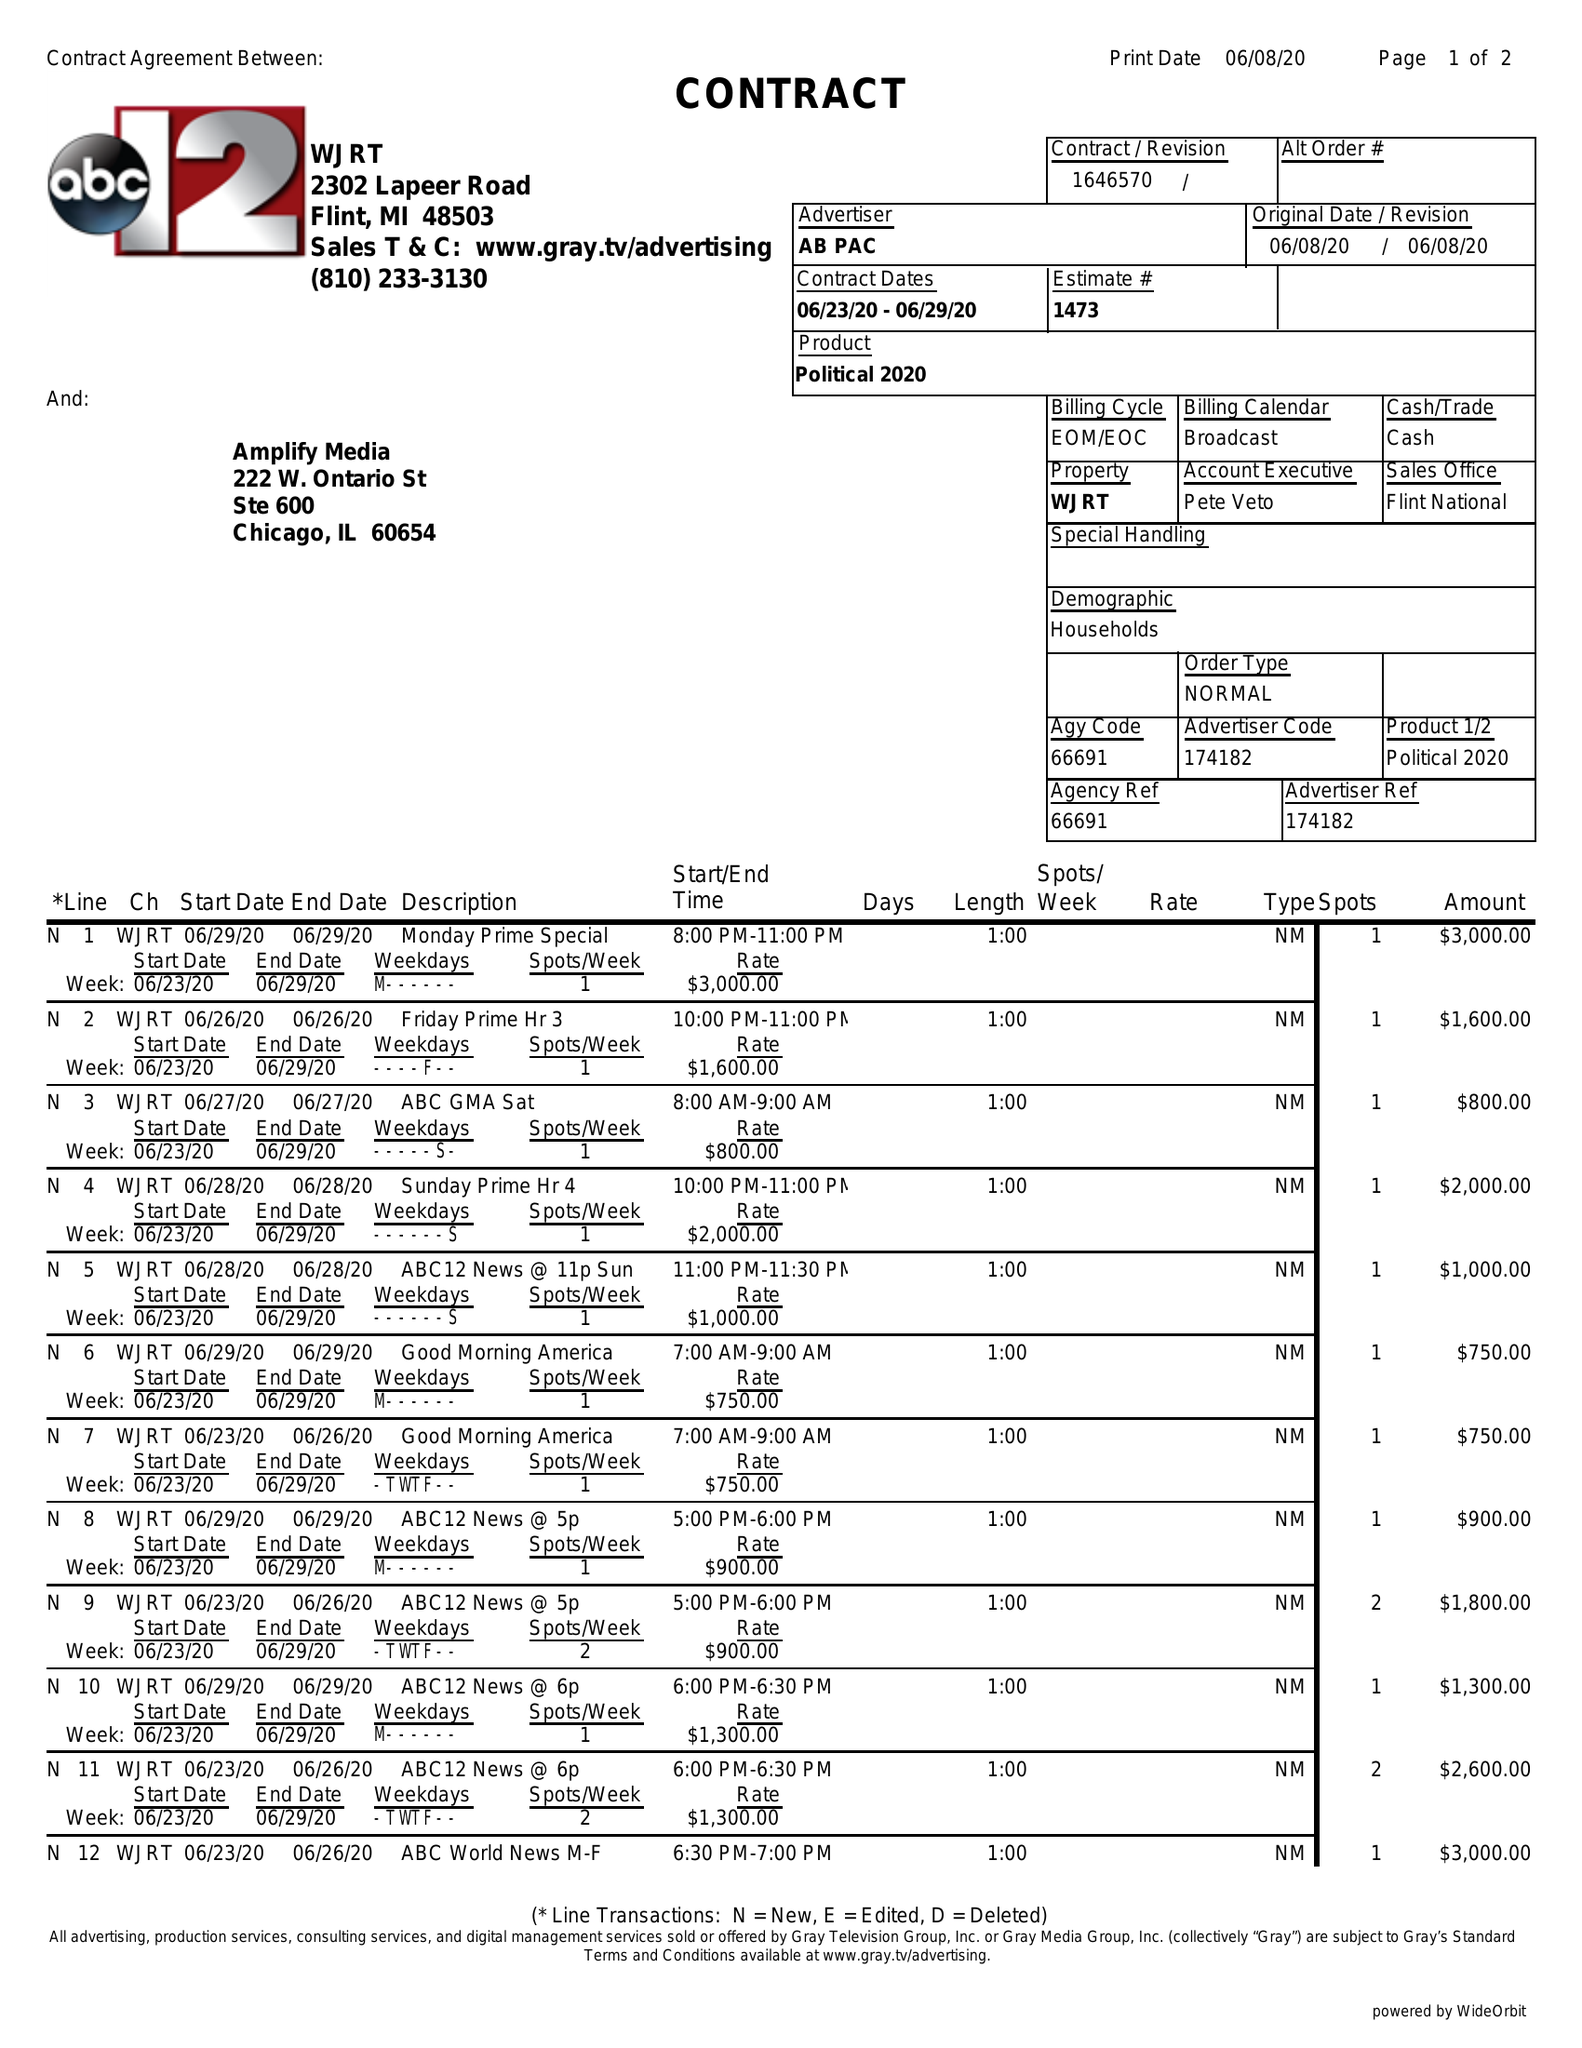What is the value for the flight_from?
Answer the question using a single word or phrase. 06/23/20 